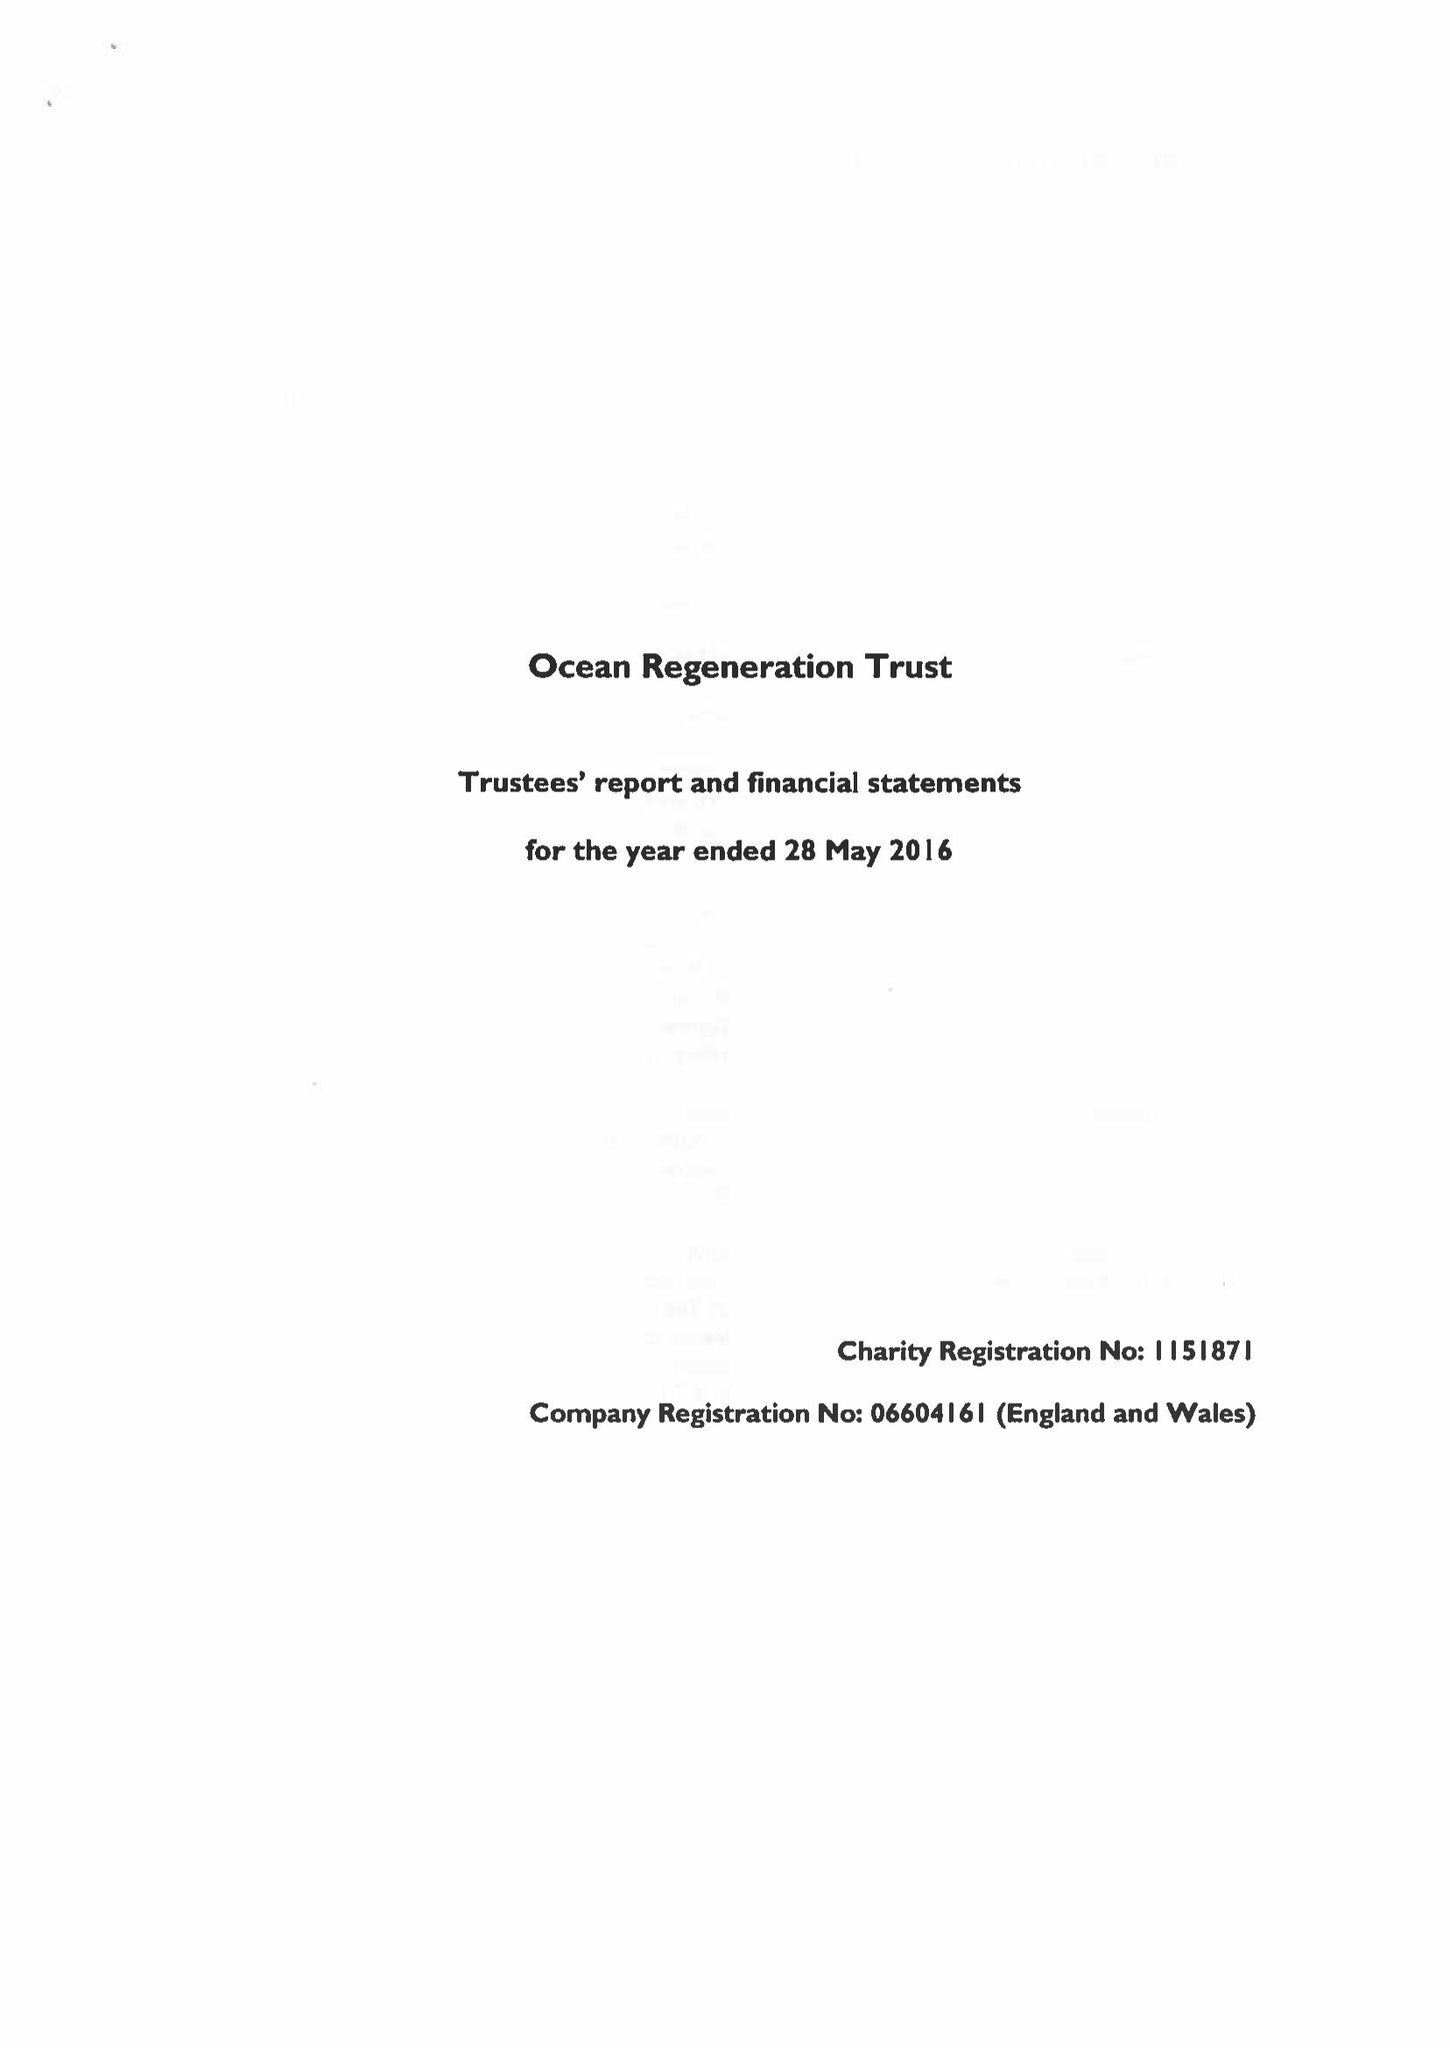What is the value for the report_date?
Answer the question using a single word or phrase. 2016-05-28 